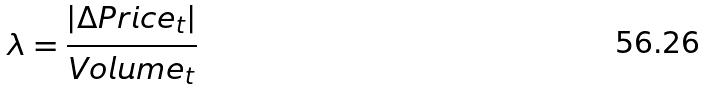Convert formula to latex. <formula><loc_0><loc_0><loc_500><loc_500>\lambda = \frac { | \Delta P r i c e _ { t } | } { V o l u m e _ { t } }</formula> 